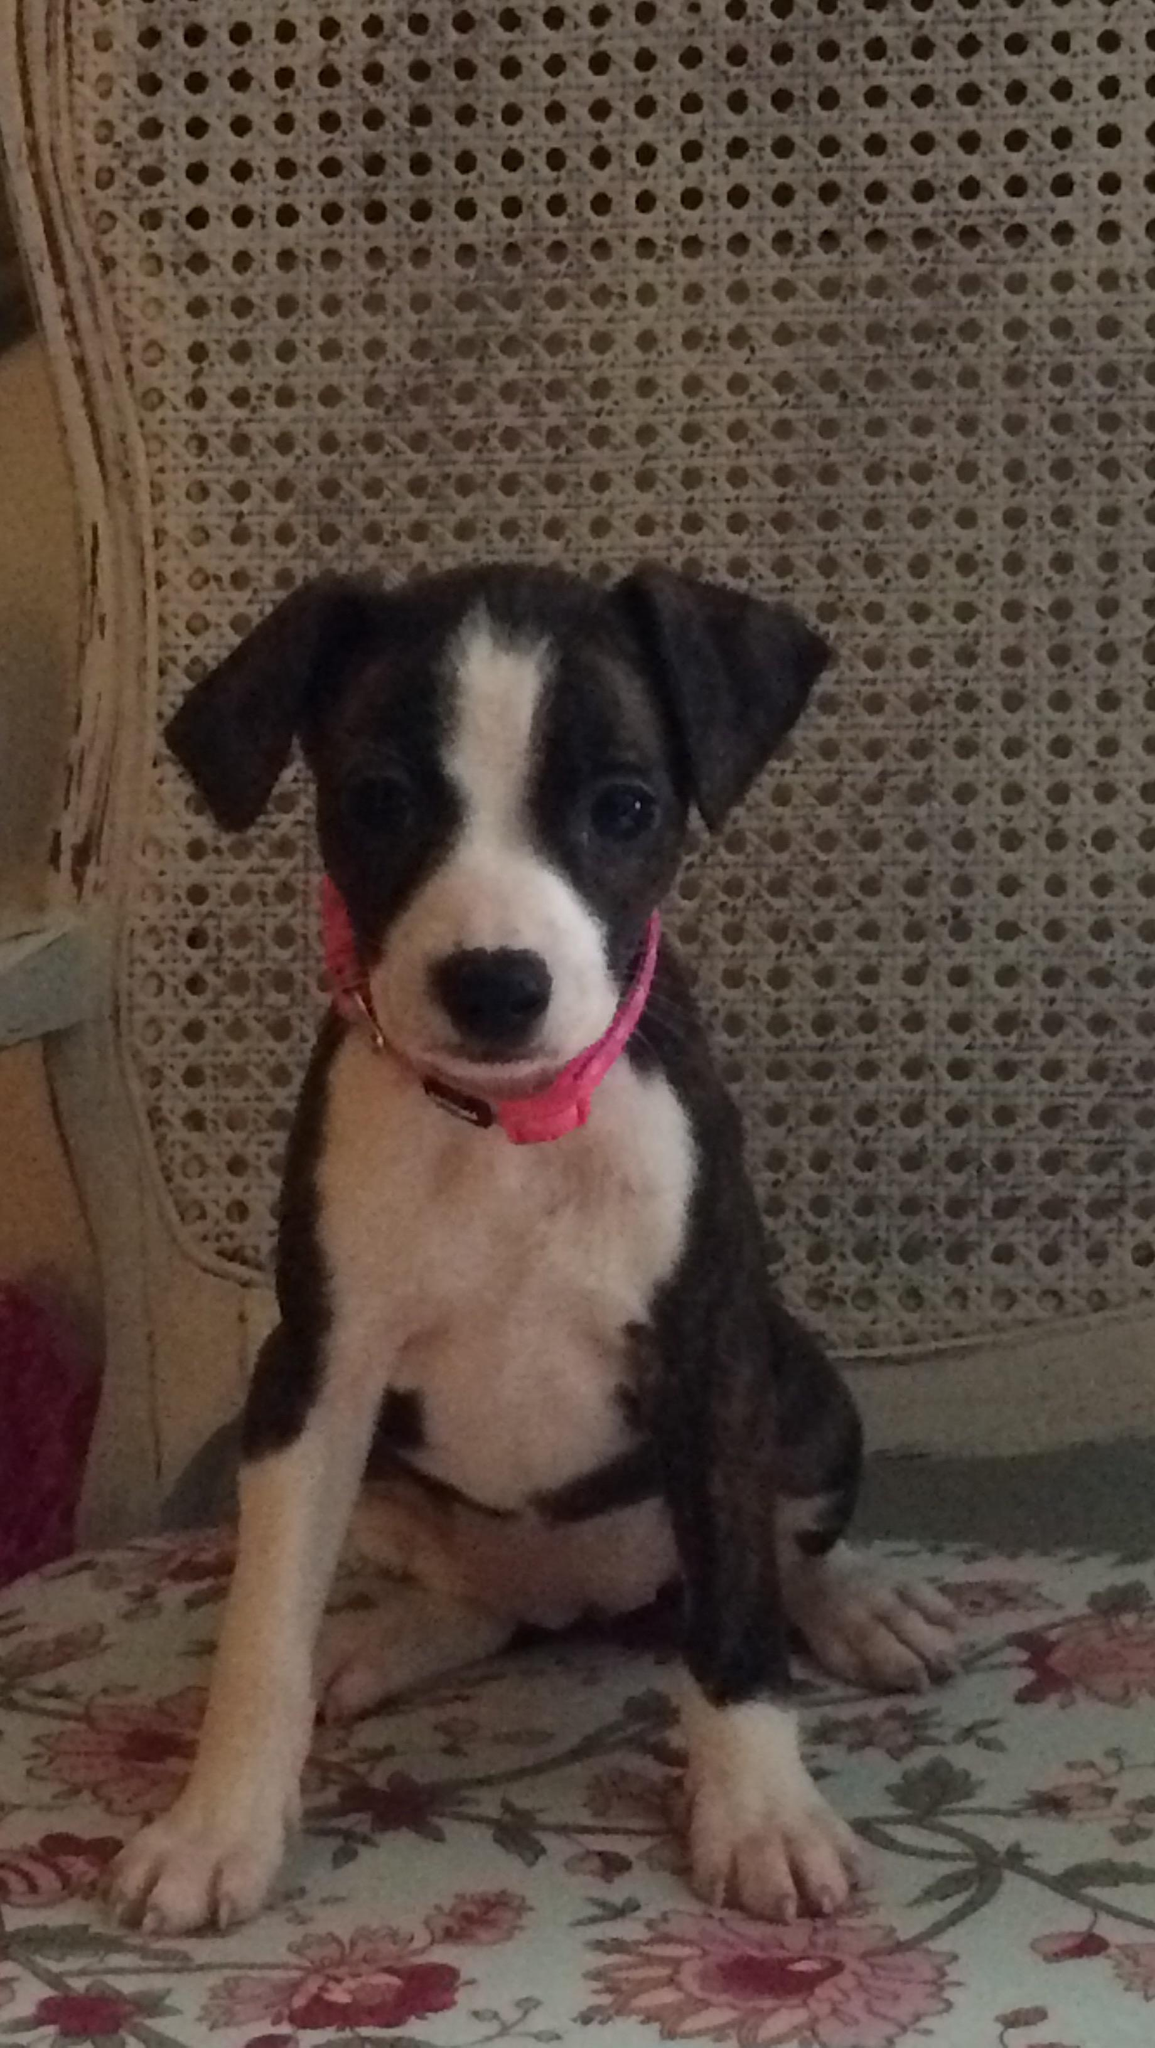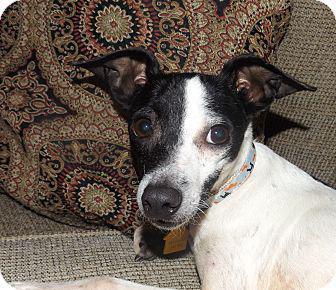The first image is the image on the left, the second image is the image on the right. Given the left and right images, does the statement "The dog in the image on the right is sitting in the grass outside." hold true? Answer yes or no. No. The first image is the image on the left, the second image is the image on the right. For the images displayed, is the sentence "The dog on the left wears a collar and stands on all fours, and the dog on the right is in a grassy spot and has black-and-white coloring." factually correct? Answer yes or no. No. 